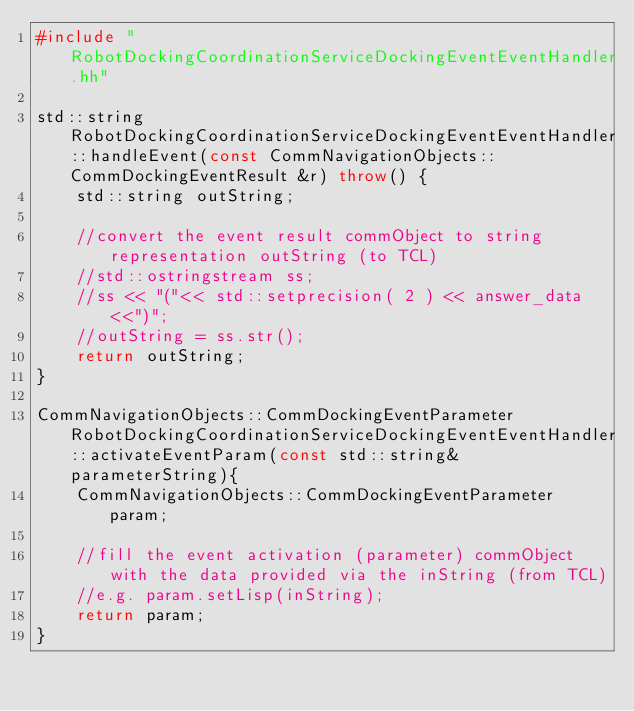<code> <loc_0><loc_0><loc_500><loc_500><_C++_>#include "RobotDockingCoordinationServiceDockingEventEventHandler.hh"

std::string RobotDockingCoordinationServiceDockingEventEventHandler::handleEvent(const CommNavigationObjects::CommDockingEventResult &r) throw() {
	std::string outString;
	
	//convert the event result commObject to string representation outString (to TCL)
	//std::ostringstream ss;
	//ss << "("<< std::setprecision( 2 ) << answer_data<<")";
	//outString = ss.str();
	return outString;
}

CommNavigationObjects::CommDockingEventParameter RobotDockingCoordinationServiceDockingEventEventHandler::activateEventParam(const std::string& parameterString){
	CommNavigationObjects::CommDockingEventParameter param;
	
	//fill the event activation (parameter) commObject with the data provided via the inString (from TCL)
	//e.g. param.setLisp(inString);
	return param;
}
</code> 